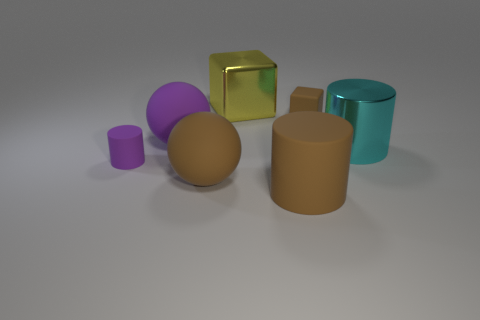Subtract all big cylinders. How many cylinders are left? 1 Subtract 1 cylinders. How many cylinders are left? 2 Add 2 big metal cylinders. How many objects exist? 9 Subtract all spheres. How many objects are left? 5 Add 2 large rubber cylinders. How many large rubber cylinders are left? 3 Add 1 tiny matte things. How many tiny matte things exist? 3 Subtract 1 brown balls. How many objects are left? 6 Subtract all small red matte objects. Subtract all yellow metallic cubes. How many objects are left? 6 